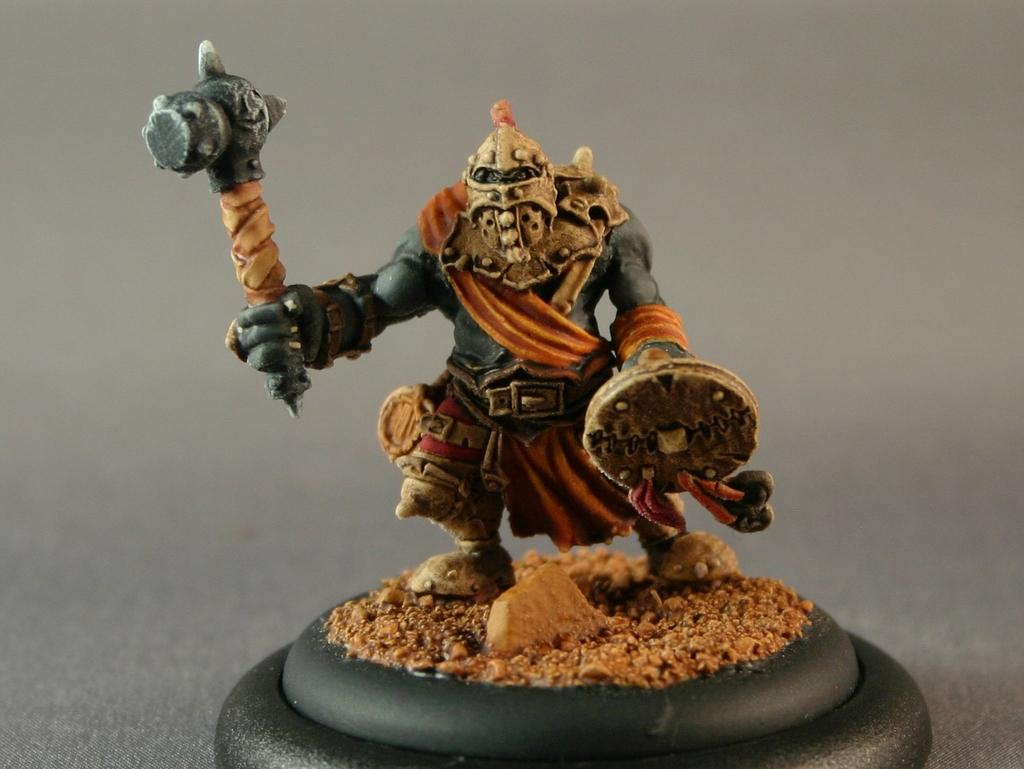What is the main subject of the image? There is a small statue in the image. What is depicted on the statue? The statue has a person depicted in it. What is the person holding in each hand? The person is holding a shield with one hand and a hammer with the other hand. What type of plants can be seen growing around the statue in the image? There are no plants visible in the image; it only features the small statue with a person holding a shield and a hammer. 